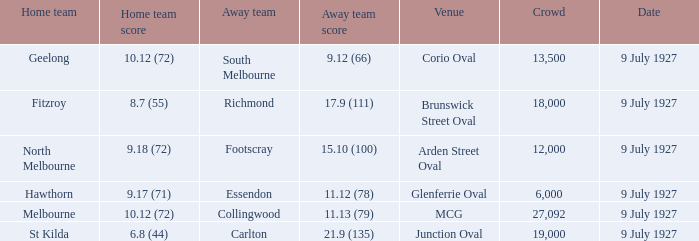When fitzroy was the home team, what was the biggest crowd recorded? 18000.0. 